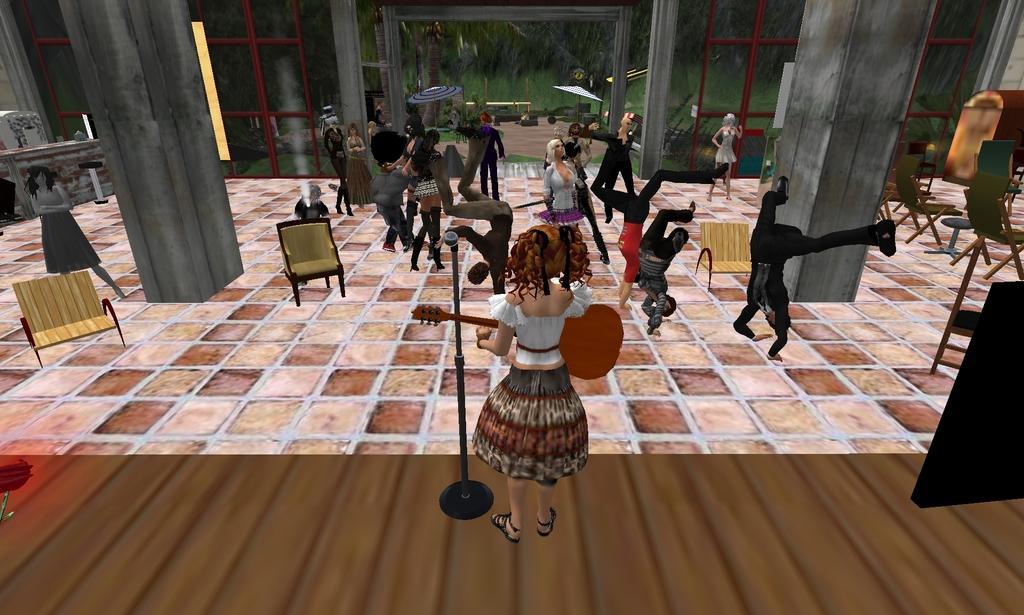Describe this image in one or two sentences. It is an animation, in the middle a woman is standing and playing the guitar, there are few people performing the different actions in this image. 